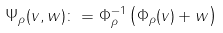Convert formula to latex. <formula><loc_0><loc_0><loc_500><loc_500>\Psi _ { \rho } ( v , w ) \colon = \Phi _ { \rho } ^ { - 1 } \left ( \Phi _ { \rho } ( v ) + w \right )</formula> 